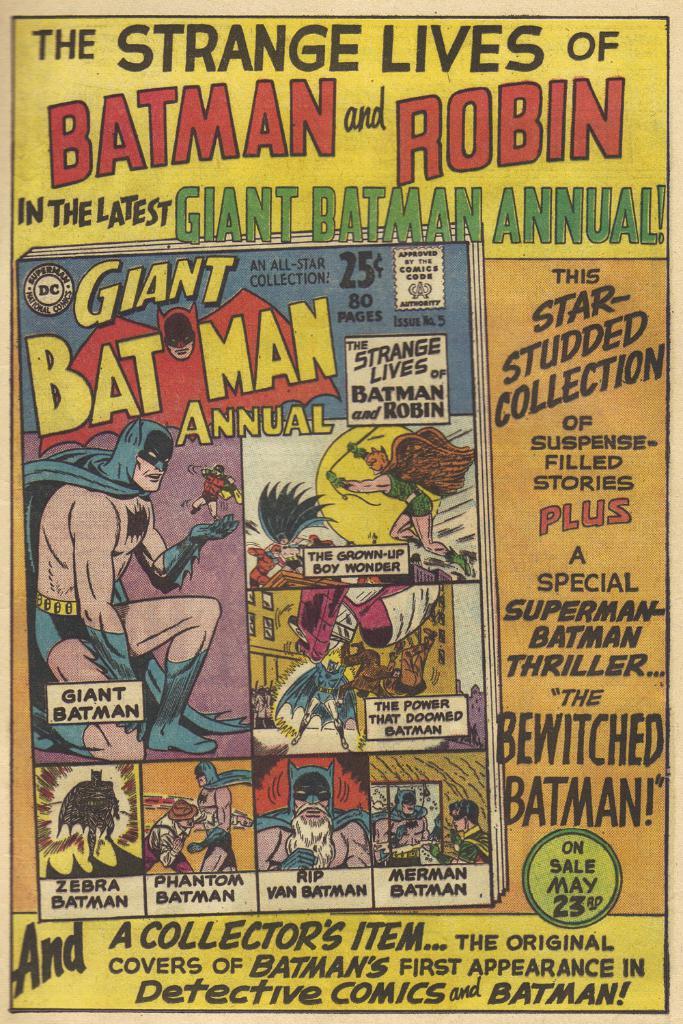What is the comic about?
Give a very brief answer. Batman and robin. How much did this comic cost?
Offer a terse response. 25 cents. 